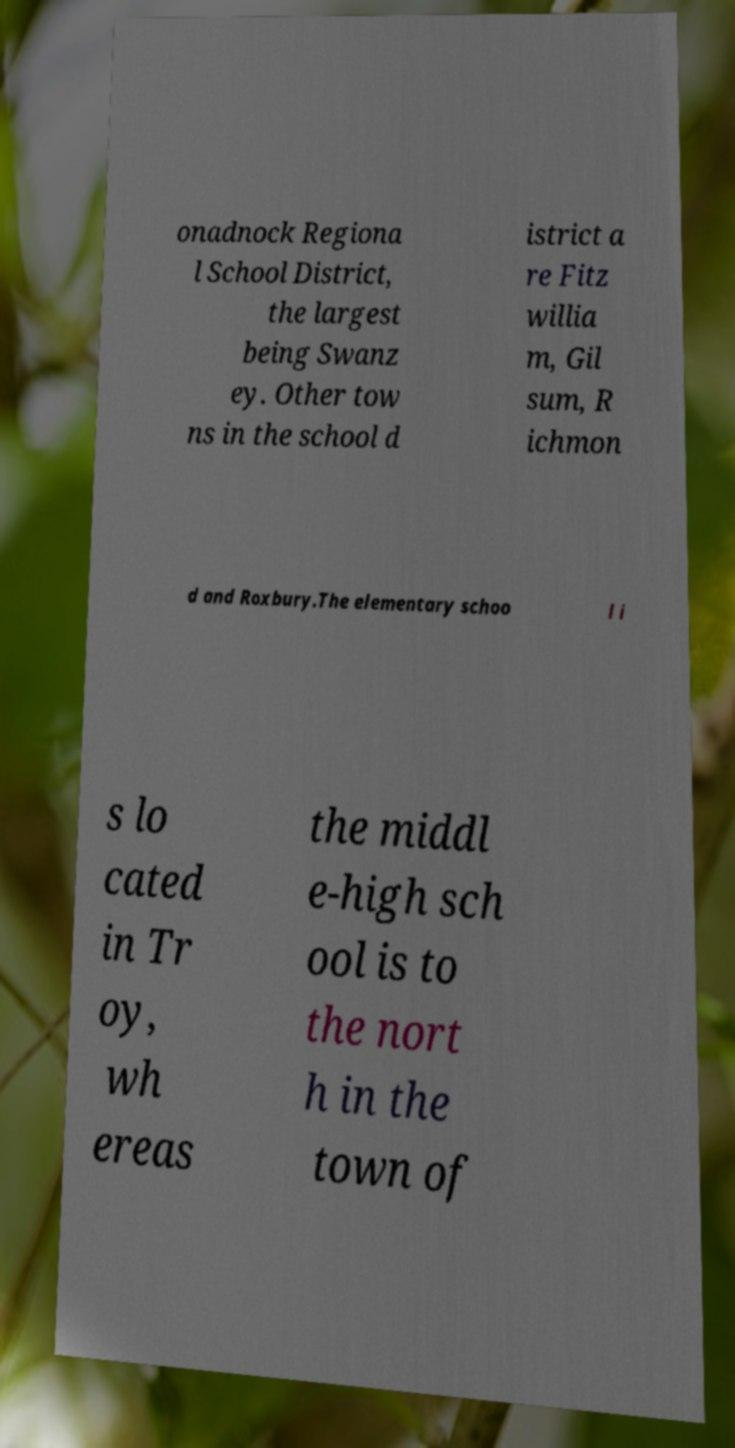Could you extract and type out the text from this image? onadnock Regiona l School District, the largest being Swanz ey. Other tow ns in the school d istrict a re Fitz willia m, Gil sum, R ichmon d and Roxbury.The elementary schoo l i s lo cated in Tr oy, wh ereas the middl e-high sch ool is to the nort h in the town of 